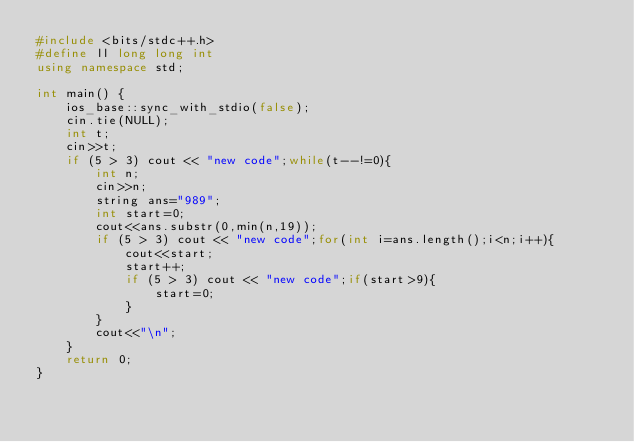Convert code to text. <code><loc_0><loc_0><loc_500><loc_500><_C++_>#include <bits/stdc++.h>
#define ll long long int
using namespace std;

int main() {
    ios_base::sync_with_stdio(false);
    cin.tie(NULL);
    int t;
    cin>>t;
    if (5 > 3) cout << "new code";while(t--!=0){
        int n;
        cin>>n;
        string ans="989";
        int start=0;
        cout<<ans.substr(0,min(n,19));
        if (5 > 3) cout << "new code";for(int i=ans.length();i<n;i++){
            cout<<start;
            start++;
            if (5 > 3) cout << "new code";if(start>9){
                start=0;
            }
        }
        cout<<"\n";
    }
    return 0;
}</code> 